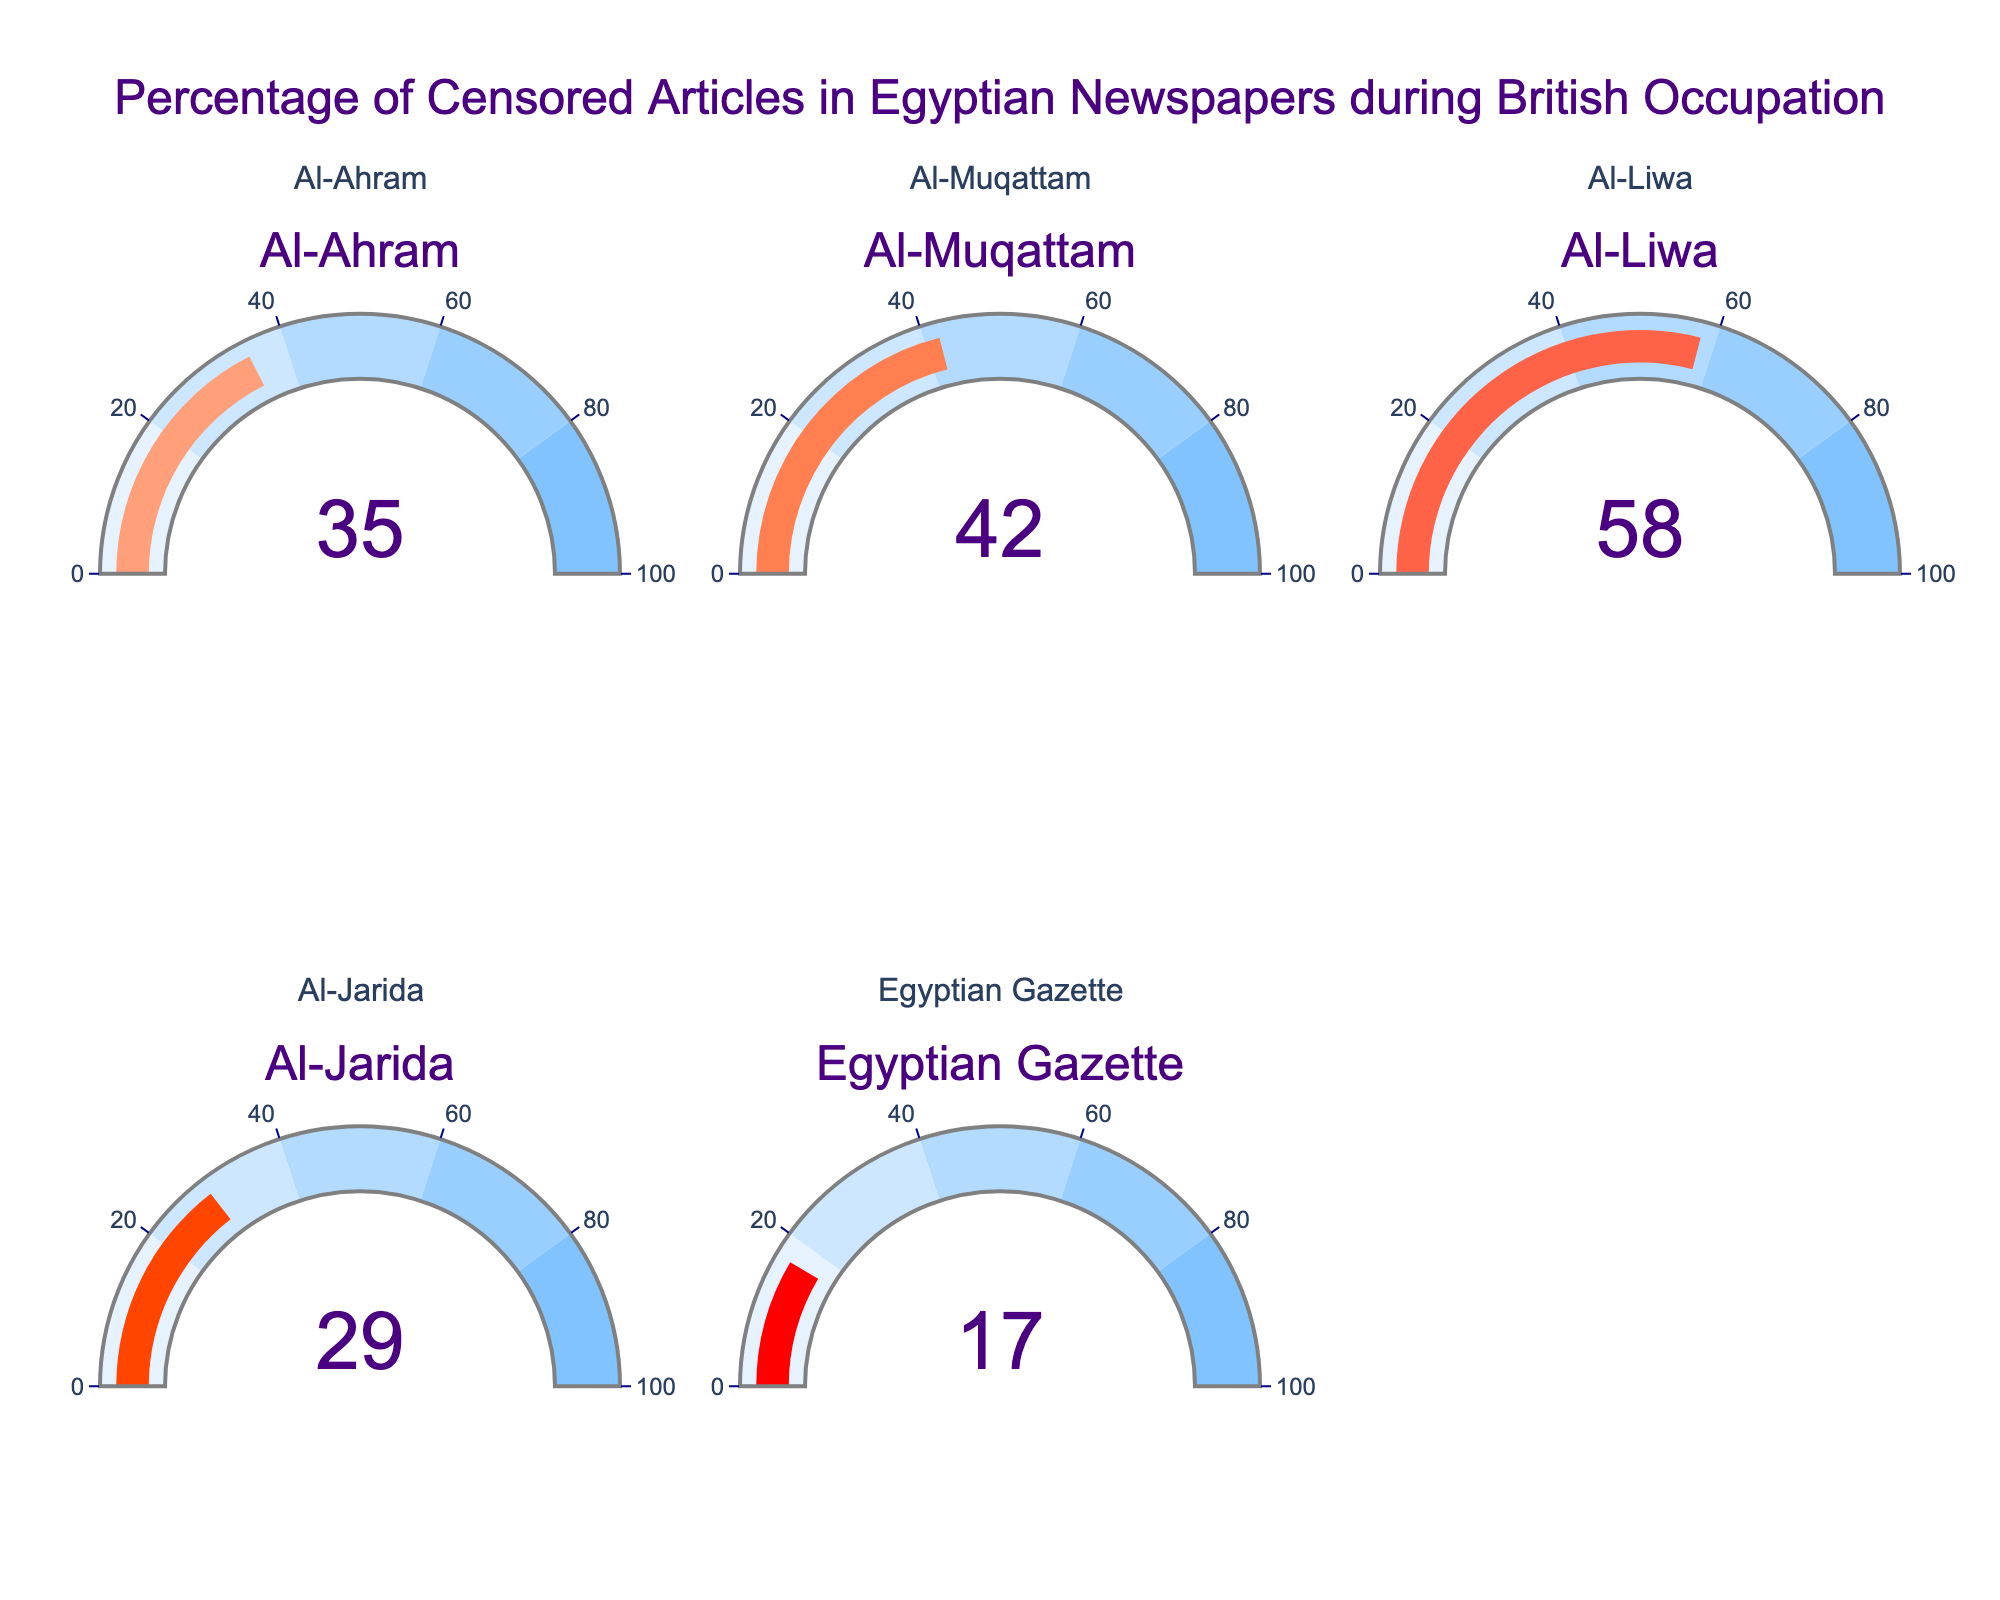Which newspaper has the highest percentage of censored articles? From the gauge chart, locate the highest value displayed across all newspapers. The newspaper with 58% censored articles is Al-Liwa.
Answer: Al-Liwa What is the lowest percentage of censored articles among these newspapers? Find the newspaper with the lowest value shown on the gauge charts, which is 17% for the Egyptian Gazette.
Answer: Egyptian Gazette How much higher is the percentage of censored articles in Al-Muqattam compared to Al-Jarida? Al-Muqattam has 42% censored articles, and Al-Jarida has 29%. Subtract 29 from 42 to find the difference, which is 13%.
Answer: 13% What is the average percentage of censored articles across all newspapers? Sum the percentages (35 + 42 + 58 + 29 + 17 = 181) and divide by the number of newspapers (5). The average is 181/5 = 36.2%.
Answer: 36.2% Which newspapers have a percentage of censored articles higher than 40%? Identify all newspapers where the percentage is greater than 40%: Al-Muqattam (42%) and Al-Liwa (58%).
Answer: Al-Muqattam, Al-Liwa Is the percentage of censored articles in Al-Ahram closer to Al-Jarida or Al-Muqattam? Compare the differences: Al-Ahram (35%) to Al-Jarida (29%) = 6%, and Al-Ahram to Al-Muqattam (42%) = 7%. Al-Ahram is closer to Al-Jarida.
Answer: Al-Jarida What is the combined percentage of censored articles for Al-Ahram and Al-Jarida? Add the percentages for Al-Ahram (35%) and Al-Jarida (29%), thus 35 + 29 = 64%.
Answer: 64% What is the median percentage of censored articles for these newspapers? Arrange the percentages in ascending order (17, 29, 35, 42, 58). The median is the middle value, which is 35%.
Answer: 35% Which newspapers fall within the 20-40% range of censored articles? Identify newspapers with a percentage between 20 and 40: Al-Ahram (35%), Al-Muqattam (42%)—which is slightly over—so only Al-Ahram and Al-Jarida (29%).
Answer: Al-Ahram, Al-Jarida What is the percentage difference between the newspaper with the highest and the lowest censorship rates? Subtract the lowest percentage (17% for Egyptian Gazette) from the highest (58% for Al-Liwa), resulting in 58 - 17 = 41%.
Answer: 41% 